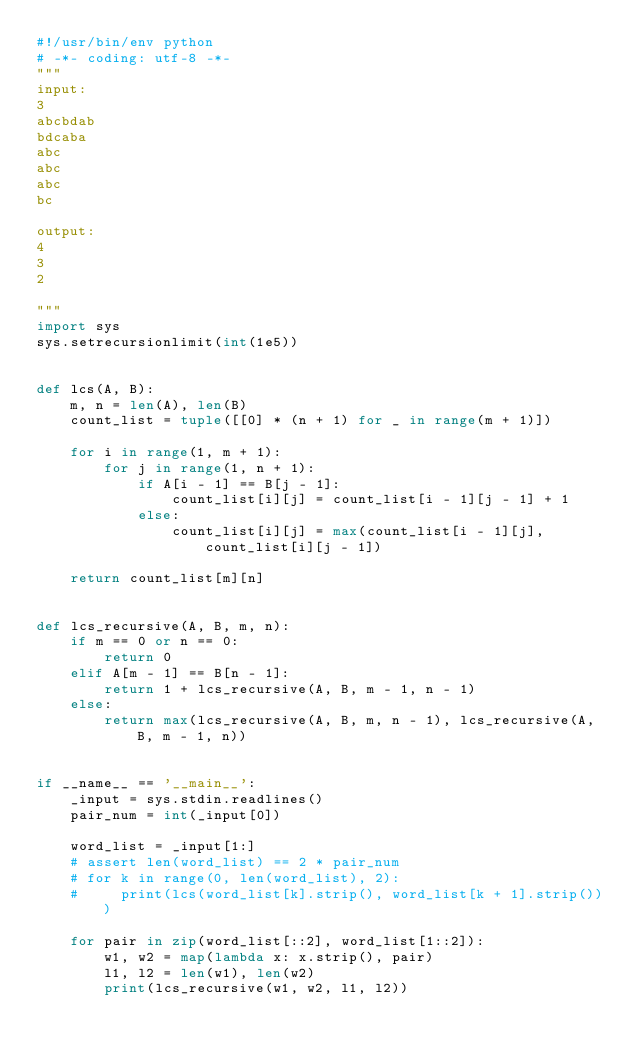Convert code to text. <code><loc_0><loc_0><loc_500><loc_500><_Python_>#!/usr/bin/env python
# -*- coding: utf-8 -*-
"""
input:
3
abcbdab
bdcaba
abc
abc
abc
bc

output:
4
3
2

"""
import sys
sys.setrecursionlimit(int(1e5))


def lcs(A, B):
    m, n = len(A), len(B)
    count_list = tuple([[0] * (n + 1) for _ in range(m + 1)])

    for i in range(1, m + 1):
        for j in range(1, n + 1):
            if A[i - 1] == B[j - 1]:
                count_list[i][j] = count_list[i - 1][j - 1] + 1
            else:
                count_list[i][j] = max(count_list[i - 1][j], count_list[i][j - 1])

    return count_list[m][n]


def lcs_recursive(A, B, m, n):
    if m == 0 or n == 0:
        return 0
    elif A[m - 1] == B[n - 1]:
        return 1 + lcs_recursive(A, B, m - 1, n - 1)
    else:
        return max(lcs_recursive(A, B, m, n - 1), lcs_recursive(A, B, m - 1, n))


if __name__ == '__main__':
    _input = sys.stdin.readlines()
    pair_num = int(_input[0])

    word_list = _input[1:]
    # assert len(word_list) == 2 * pair_num
    # for k in range(0, len(word_list), 2):
    #     print(lcs(word_list[k].strip(), word_list[k + 1].strip()))

    for pair in zip(word_list[::2], word_list[1::2]):
        w1, w2 = map(lambda x: x.strip(), pair)
        l1, l2 = len(w1), len(w2)
        print(lcs_recursive(w1, w2, l1, l2))</code> 